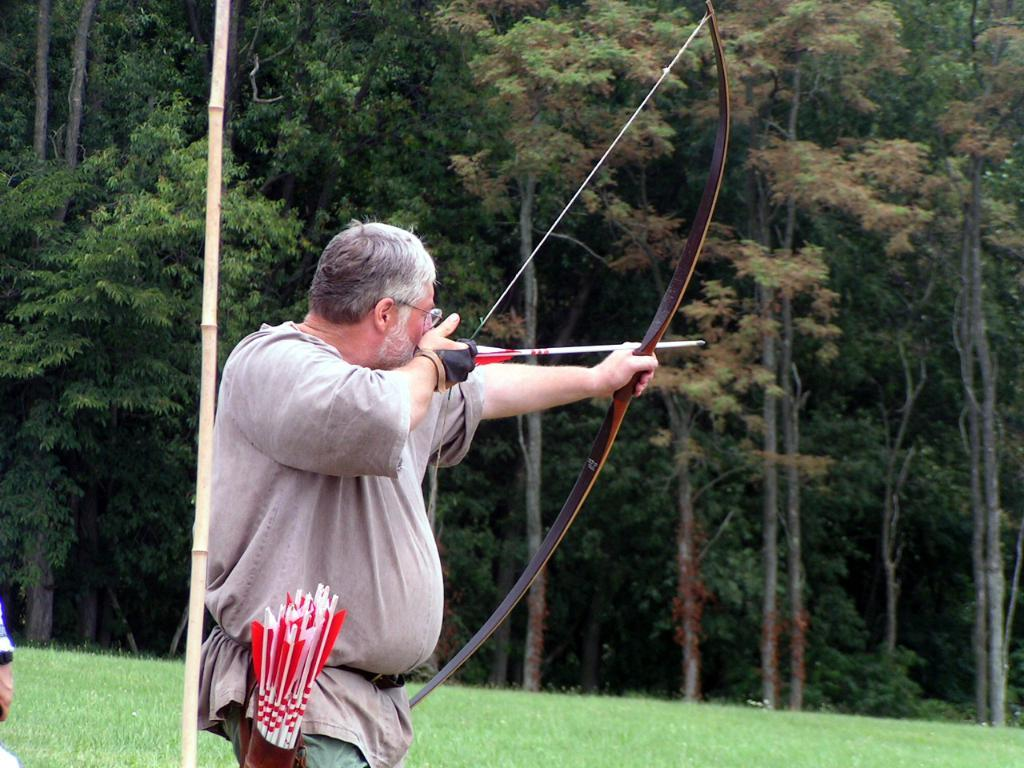What is the main subject of the image? There is a man in the image. What is the man doing in the image? The man is using a longbow and arrow. What type of plant can be seen behind the man? There is a bamboo plant behind the man. What can be seen in the background of the image? The background of the image contains trees. What type of vegetation covers the land in the image? The land in the image is covered with grass. What type of art can be seen on the man's shirt in the image? There is no art visible on the man's shirt in the image. What type of bird is the man observing during his journey in the image? There is no bird or journey depicted in the image; it features a man using a longbow and arrow. 